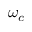<formula> <loc_0><loc_0><loc_500><loc_500>\omega _ { c }</formula> 